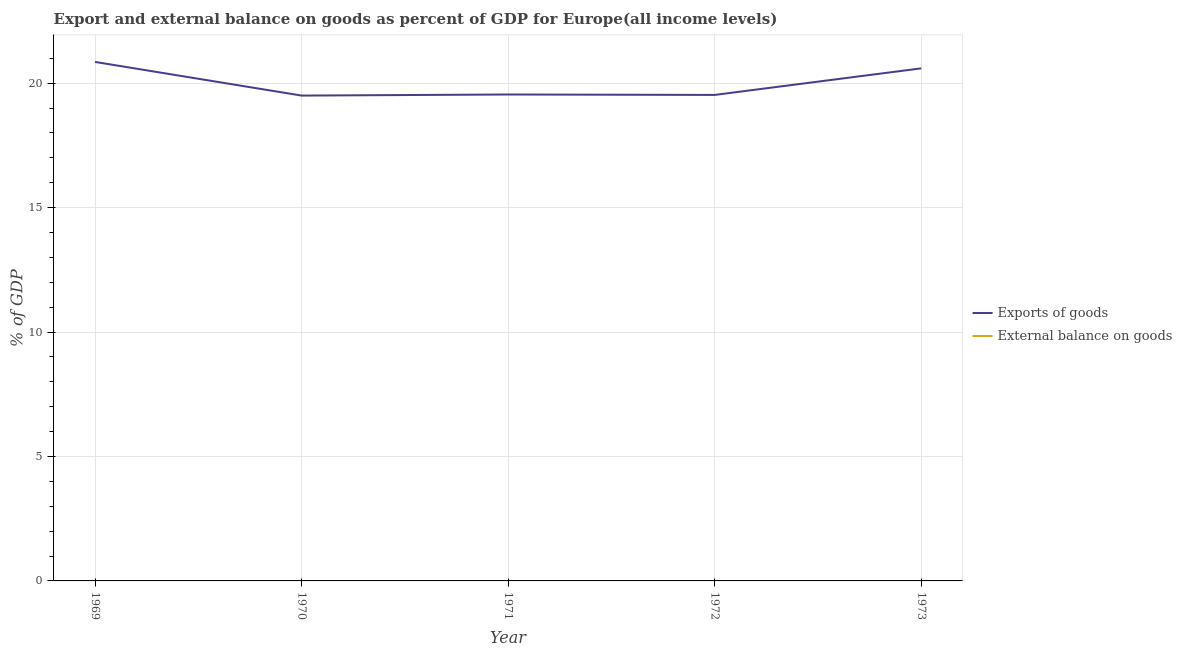What is the export of goods as percentage of gdp in 1972?
Ensure brevity in your answer.  19.53. Across all years, what is the maximum export of goods as percentage of gdp?
Your answer should be compact. 20.85. Across all years, what is the minimum export of goods as percentage of gdp?
Offer a terse response. 19.5. In which year was the export of goods as percentage of gdp maximum?
Your answer should be compact. 1969. What is the total external balance on goods as percentage of gdp in the graph?
Your answer should be compact. 0. What is the difference between the export of goods as percentage of gdp in 1970 and that in 1971?
Give a very brief answer. -0.04. What is the difference between the export of goods as percentage of gdp in 1969 and the external balance on goods as percentage of gdp in 1973?
Offer a terse response. 20.85. What is the average external balance on goods as percentage of gdp per year?
Offer a very short reply. 0. What is the ratio of the export of goods as percentage of gdp in 1971 to that in 1973?
Your answer should be very brief. 0.95. What is the difference between the highest and the second highest export of goods as percentage of gdp?
Your response must be concise. 0.26. What is the difference between the highest and the lowest export of goods as percentage of gdp?
Offer a terse response. 1.35. In how many years, is the external balance on goods as percentage of gdp greater than the average external balance on goods as percentage of gdp taken over all years?
Provide a short and direct response. 0. Does the export of goods as percentage of gdp monotonically increase over the years?
Provide a short and direct response. No. How many lines are there?
Provide a short and direct response. 1. How many years are there in the graph?
Offer a very short reply. 5. Are the values on the major ticks of Y-axis written in scientific E-notation?
Your answer should be compact. No. Does the graph contain any zero values?
Provide a succinct answer. Yes. Does the graph contain grids?
Make the answer very short. Yes. Where does the legend appear in the graph?
Keep it short and to the point. Center right. How are the legend labels stacked?
Keep it short and to the point. Vertical. What is the title of the graph?
Your answer should be compact. Export and external balance on goods as percent of GDP for Europe(all income levels). Does "Arms imports" appear as one of the legend labels in the graph?
Ensure brevity in your answer.  No. What is the label or title of the X-axis?
Ensure brevity in your answer.  Year. What is the label or title of the Y-axis?
Provide a short and direct response. % of GDP. What is the % of GDP of Exports of goods in 1969?
Your answer should be very brief. 20.85. What is the % of GDP of Exports of goods in 1970?
Provide a short and direct response. 19.5. What is the % of GDP of Exports of goods in 1971?
Your answer should be very brief. 19.54. What is the % of GDP of External balance on goods in 1971?
Provide a short and direct response. 0. What is the % of GDP of Exports of goods in 1972?
Provide a short and direct response. 19.53. What is the % of GDP of Exports of goods in 1973?
Ensure brevity in your answer.  20.59. Across all years, what is the maximum % of GDP of Exports of goods?
Provide a succinct answer. 20.85. Across all years, what is the minimum % of GDP of Exports of goods?
Provide a short and direct response. 19.5. What is the total % of GDP in Exports of goods in the graph?
Your answer should be compact. 100.02. What is the difference between the % of GDP in Exports of goods in 1969 and that in 1970?
Provide a succinct answer. 1.35. What is the difference between the % of GDP of Exports of goods in 1969 and that in 1971?
Your answer should be compact. 1.31. What is the difference between the % of GDP in Exports of goods in 1969 and that in 1972?
Your answer should be compact. 1.33. What is the difference between the % of GDP of Exports of goods in 1969 and that in 1973?
Give a very brief answer. 0.26. What is the difference between the % of GDP in Exports of goods in 1970 and that in 1971?
Your answer should be compact. -0.04. What is the difference between the % of GDP in Exports of goods in 1970 and that in 1972?
Offer a very short reply. -0.03. What is the difference between the % of GDP in Exports of goods in 1970 and that in 1973?
Make the answer very short. -1.09. What is the difference between the % of GDP in Exports of goods in 1971 and that in 1972?
Provide a short and direct response. 0.02. What is the difference between the % of GDP of Exports of goods in 1971 and that in 1973?
Offer a terse response. -1.05. What is the difference between the % of GDP in Exports of goods in 1972 and that in 1973?
Your answer should be very brief. -1.07. What is the average % of GDP of Exports of goods per year?
Your answer should be very brief. 20. What is the ratio of the % of GDP in Exports of goods in 1969 to that in 1970?
Keep it short and to the point. 1.07. What is the ratio of the % of GDP of Exports of goods in 1969 to that in 1971?
Make the answer very short. 1.07. What is the ratio of the % of GDP in Exports of goods in 1969 to that in 1972?
Provide a short and direct response. 1.07. What is the ratio of the % of GDP of Exports of goods in 1969 to that in 1973?
Keep it short and to the point. 1.01. What is the ratio of the % of GDP in Exports of goods in 1970 to that in 1971?
Provide a short and direct response. 1. What is the ratio of the % of GDP of Exports of goods in 1970 to that in 1972?
Keep it short and to the point. 1. What is the ratio of the % of GDP in Exports of goods in 1970 to that in 1973?
Your answer should be very brief. 0.95. What is the ratio of the % of GDP in Exports of goods in 1971 to that in 1973?
Offer a very short reply. 0.95. What is the ratio of the % of GDP of Exports of goods in 1972 to that in 1973?
Make the answer very short. 0.95. What is the difference between the highest and the second highest % of GDP in Exports of goods?
Your answer should be very brief. 0.26. What is the difference between the highest and the lowest % of GDP of Exports of goods?
Offer a terse response. 1.35. 